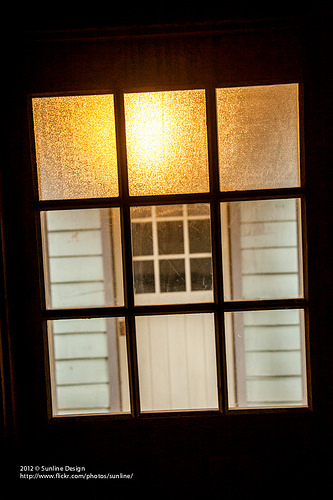<image>
Is the window above the door? Yes. The window is positioned above the door in the vertical space, higher up in the scene. 